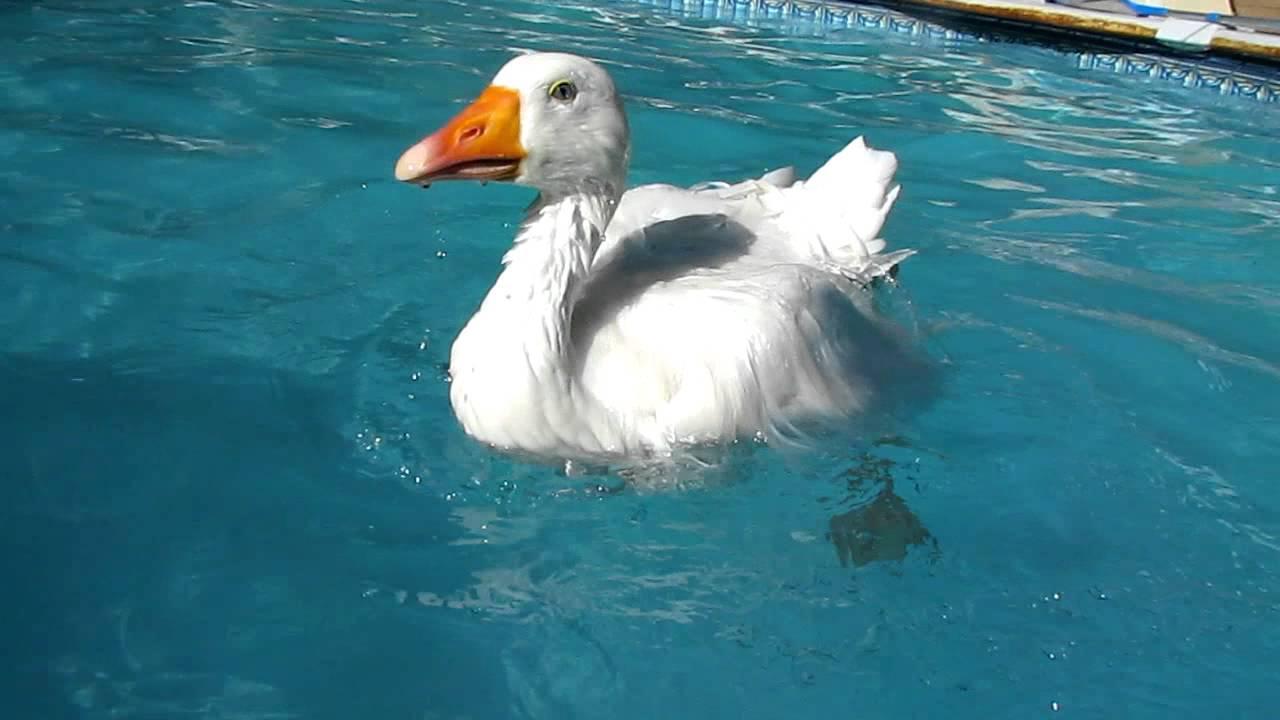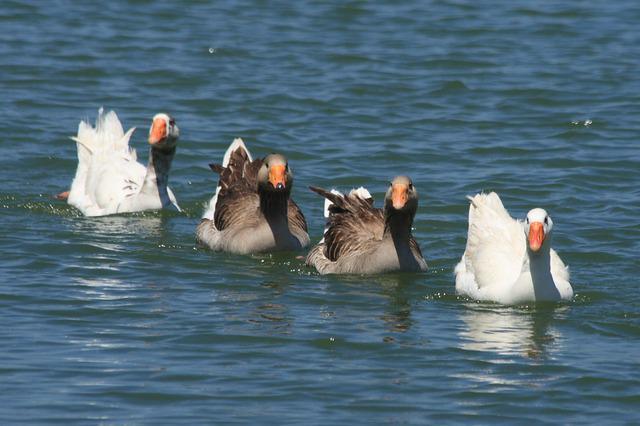The first image is the image on the left, the second image is the image on the right. Considering the images on both sides, is "Some of the birds are darker than the others." valid? Answer yes or no. Yes. The first image is the image on the left, the second image is the image on the right. For the images displayed, is the sentence "There are more than three ducks in water." factually correct? Answer yes or no. Yes. 